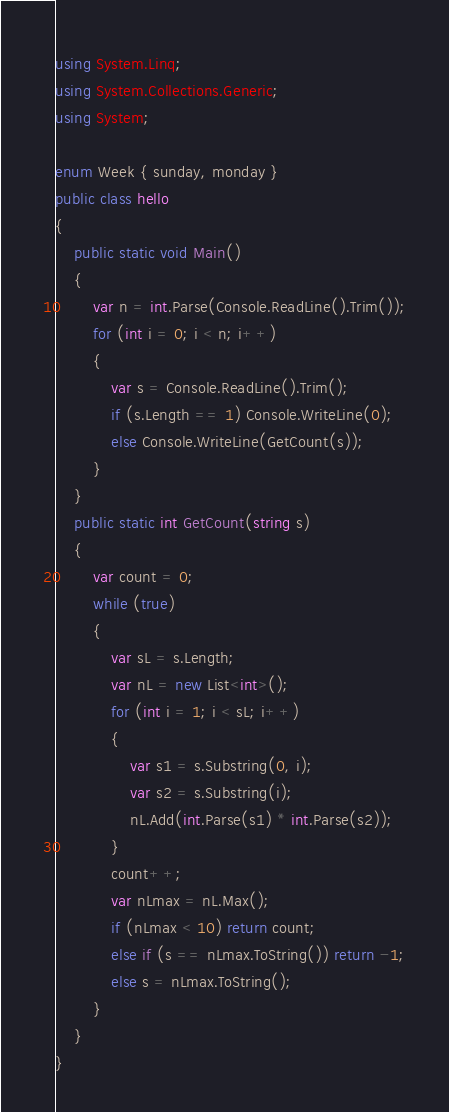<code> <loc_0><loc_0><loc_500><loc_500><_C#_>using System.Linq;
using System.Collections.Generic;
using System;

enum Week { sunday, monday }
public class hello
{
    public static void Main()
    {
        var n = int.Parse(Console.ReadLine().Trim());
        for (int i = 0; i < n; i++)
        {
            var s = Console.ReadLine().Trim();
            if (s.Length == 1) Console.WriteLine(0);
            else Console.WriteLine(GetCount(s));
        }
    }
    public static int GetCount(string s)
    {
        var count = 0;
        while (true)
        {
            var sL = s.Length;
            var nL = new List<int>();
            for (int i = 1; i < sL; i++)
            {
                var s1 = s.Substring(0, i);
                var s2 = s.Substring(i);
                nL.Add(int.Parse(s1) * int.Parse(s2));
            }
            count++;
            var nLmax = nL.Max();
            if (nLmax < 10) return count;
            else if (s == nLmax.ToString()) return -1;
            else s = nLmax.ToString();
        }
    }
}</code> 